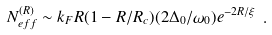Convert formula to latex. <formula><loc_0><loc_0><loc_500><loc_500>N _ { e f f } ^ { ( R ) } \sim k _ { F } R ( 1 - R / R _ { c } ) ( 2 \Delta _ { 0 } / \omega _ { 0 } ) e ^ { - 2 R / \xi } \ .</formula> 